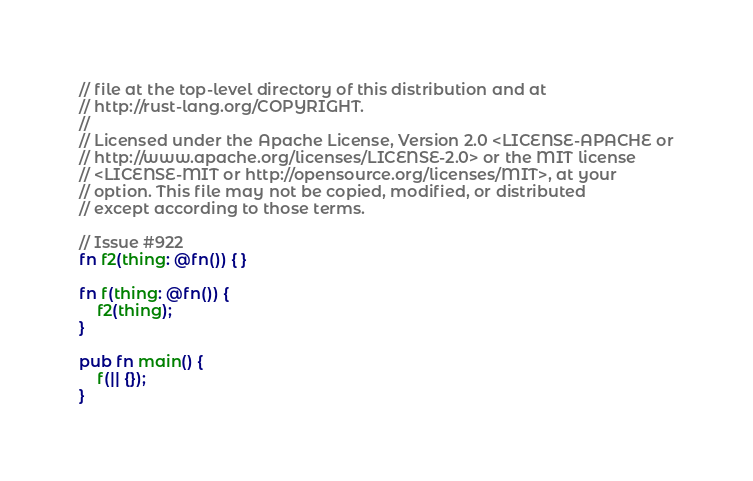Convert code to text. <code><loc_0><loc_0><loc_500><loc_500><_Rust_>// file at the top-level directory of this distribution and at
// http://rust-lang.org/COPYRIGHT.
//
// Licensed under the Apache License, Version 2.0 <LICENSE-APACHE or
// http://www.apache.org/licenses/LICENSE-2.0> or the MIT license
// <LICENSE-MIT or http://opensource.org/licenses/MIT>, at your
// option. This file may not be copied, modified, or distributed
// except according to those terms.

// Issue #922
fn f2(thing: @fn()) { }

fn f(thing: @fn()) {
    f2(thing);
}

pub fn main() {
    f(|| {});
}
</code> 